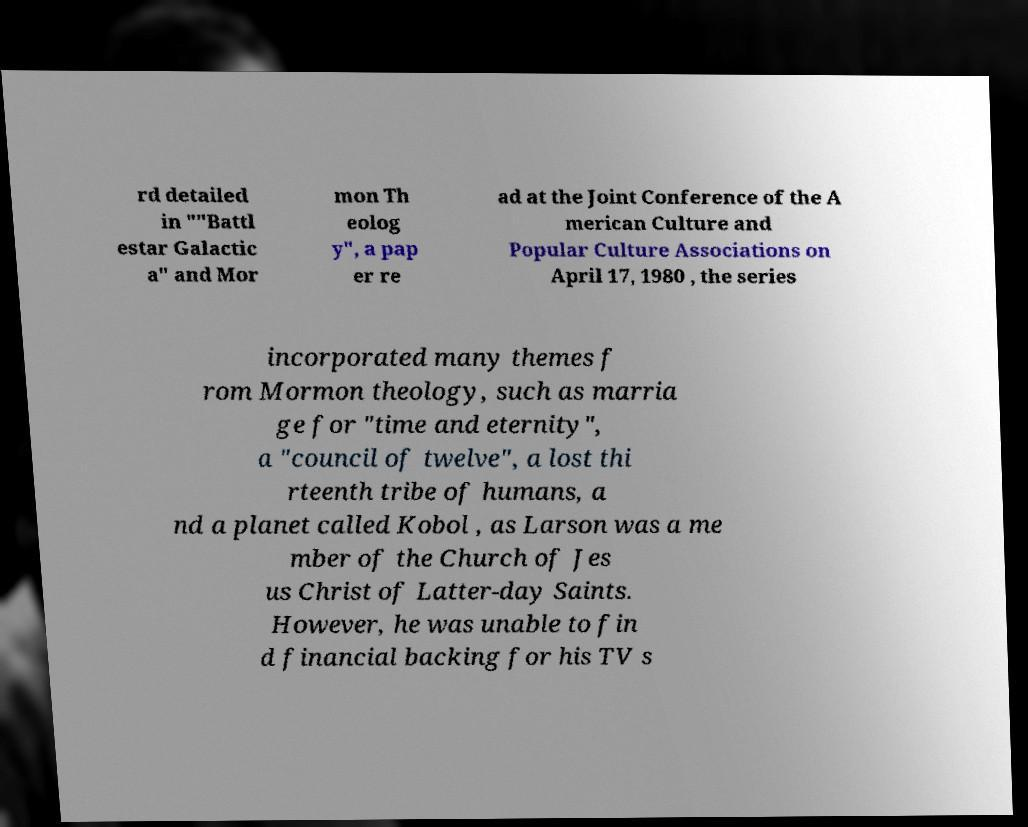What messages or text are displayed in this image? I need them in a readable, typed format. rd detailed in ""Battl estar Galactic a" and Mor mon Th eolog y", a pap er re ad at the Joint Conference of the A merican Culture and Popular Culture Associations on April 17, 1980 , the series incorporated many themes f rom Mormon theology, such as marria ge for "time and eternity", a "council of twelve", a lost thi rteenth tribe of humans, a nd a planet called Kobol , as Larson was a me mber of the Church of Jes us Christ of Latter-day Saints. However, he was unable to fin d financial backing for his TV s 